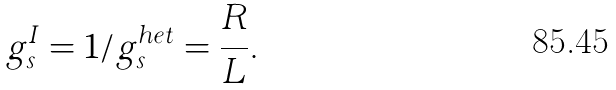<formula> <loc_0><loc_0><loc_500><loc_500>g _ { s } ^ { I } = 1 / g _ { s } ^ { h e t } = \frac { R } { L } .</formula> 